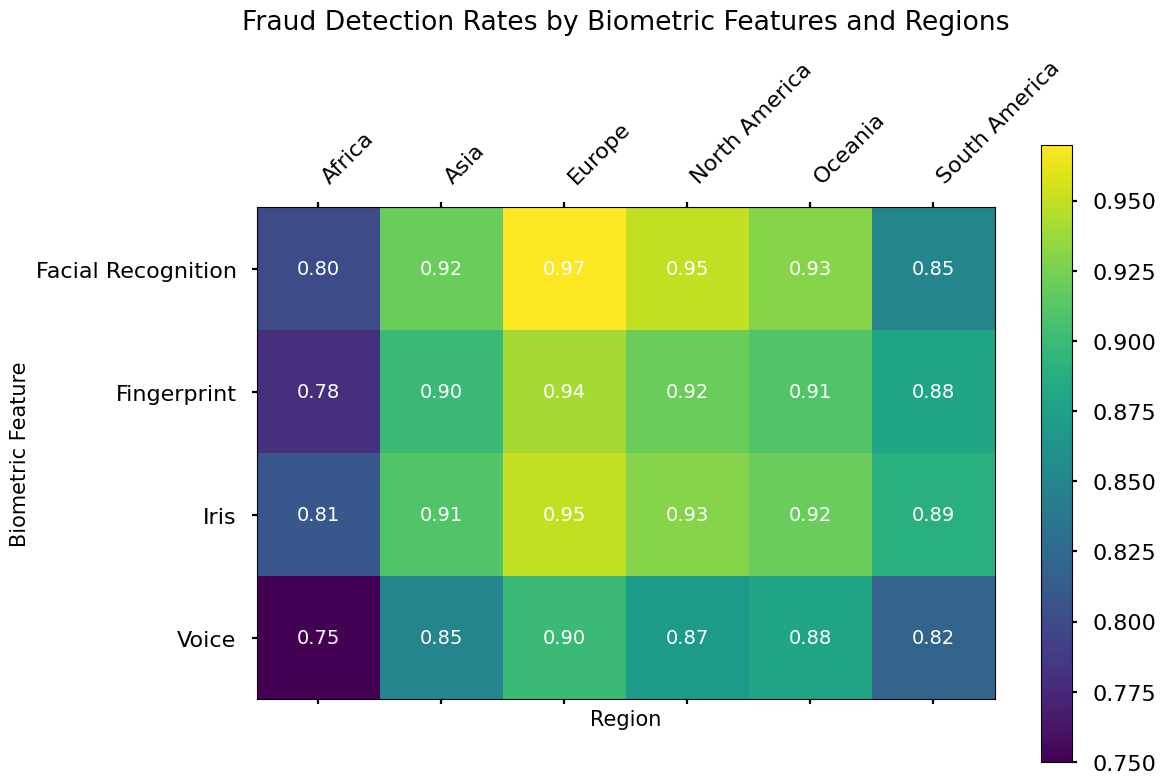Which region has the highest fraud detection rate for facial recognition? By looking at the heatmap's colors or the specific values for facial recognition across regions, Europe has the highest value of 0.97.
Answer: Europe Which biometric feature in Africa has the lowest fraud detection rate? By examining the heatmap's color gradient or the specific values for Africa, Voice has the lowest fraud detection rate of 0.75.
Answer: Voice How much higher is the fraud detection rate for facial recognition in North America compared to South America? The fraud detection rate for facial recognition in North America is 0.95, and in South America, it is 0.85. The difference is 0.95 - 0.85 = 0.10.
Answer: 0.10 Rank the regions by their average fraud detection rates for voice recognition from highest to lowest. Calculate the average fraud detection rate for voice recognition in each region by referring to the heatmap: Europe (0.90), Oceania (0.88), North America (0.87), Asia (0.85), South America (0.82), Africa (0.75).
Answer: Europe, Oceania, North America, Asia, South America, Africa What's the average fraud detection rate for fingerprint across all regions? Average the fraud detection rates for fingerprint across regions: (0.92+0.88+0.94+0.78+0.90+0.91)/6 = 0.888.
Answer: 0.888 Which region shows the widest range (difference) in fraud detection rates among the biometric features? Calculate the range for each region: Europe (0.97-0.90 = 0.07), North America (0.95-0.87 = 0.08), South America (0.89-0.82 = 0.07), Africa (0.81-0.75 = 0.06), Asia (0.92-0.85 = 0.07), Oceania (0.93-0.88 = 0.05). North America shows the widest range of 0.08.
Answer: North America What is the median fraud detection rate for Asia? Sort the rates for Asia: 0.85 (Voice), 0.90 (Fingerprint), 0.91 (Iris), 0.92 (Facial Recognition). The median value is (0.90+0.91)/2 = 0.905.
Answer: 0.905 Which biometric feature has the most consistent fraud detection rate across regions, and what is this rate? Look at the rates for each feature across regions to find the smallest range. Iris rates are: North America (0.93), South America (0.89), Europe (0.95), Africa (0.81), Asia (0.91), Oceania (0.92). The range is 0.95-0.81 = 0.14.
Answer: Iris, 0.14 